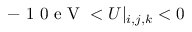Convert formula to latex. <formula><loc_0><loc_0><loc_500><loc_500>- 1 0 e V < U | _ { i , j , k } < 0</formula> 